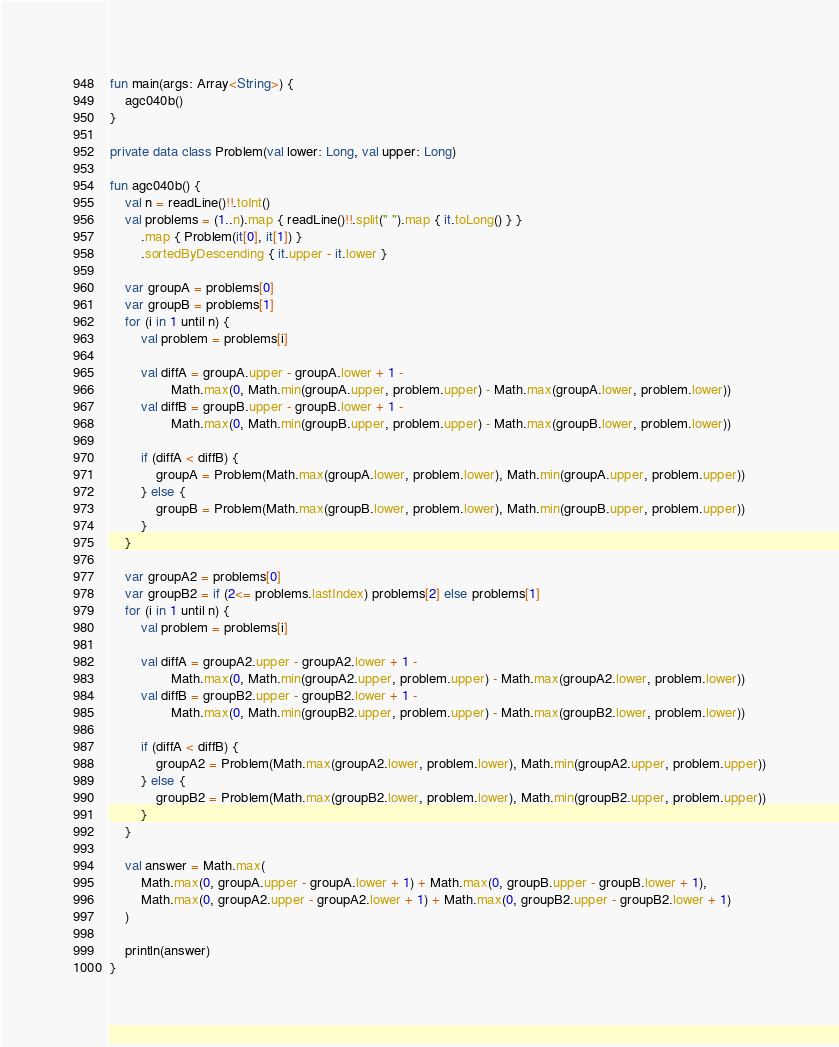<code> <loc_0><loc_0><loc_500><loc_500><_Kotlin_>fun main(args: Array<String>) {
    agc040b()
}

private data class Problem(val lower: Long, val upper: Long)

fun agc040b() {
    val n = readLine()!!.toInt()
    val problems = (1..n).map { readLine()!!.split(" ").map { it.toLong() } }
        .map { Problem(it[0], it[1]) }
        .sortedByDescending { it.upper - it.lower }

    var groupA = problems[0]
    var groupB = problems[1]
    for (i in 1 until n) {
        val problem = problems[i]

        val diffA = groupA.upper - groupA.lower + 1 -
                Math.max(0, Math.min(groupA.upper, problem.upper) - Math.max(groupA.lower, problem.lower))
        val diffB = groupB.upper - groupB.lower + 1 -
                Math.max(0, Math.min(groupB.upper, problem.upper) - Math.max(groupB.lower, problem.lower))

        if (diffA < diffB) {
            groupA = Problem(Math.max(groupA.lower, problem.lower), Math.min(groupA.upper, problem.upper))
        } else {
            groupB = Problem(Math.max(groupB.lower, problem.lower), Math.min(groupB.upper, problem.upper))
        }
    }

    var groupA2 = problems[0]
    var groupB2 = if (2<= problems.lastIndex) problems[2] else problems[1]
    for (i in 1 until n) {
        val problem = problems[i]

        val diffA = groupA2.upper - groupA2.lower + 1 -
                Math.max(0, Math.min(groupA2.upper, problem.upper) - Math.max(groupA2.lower, problem.lower))
        val diffB = groupB2.upper - groupB2.lower + 1 -
                Math.max(0, Math.min(groupB2.upper, problem.upper) - Math.max(groupB2.lower, problem.lower))

        if (diffA < diffB) {
            groupA2 = Problem(Math.max(groupA2.lower, problem.lower), Math.min(groupA2.upper, problem.upper))
        } else {
            groupB2 = Problem(Math.max(groupB2.lower, problem.lower), Math.min(groupB2.upper, problem.upper))
        }
    }

    val answer = Math.max(
        Math.max(0, groupA.upper - groupA.lower + 1) + Math.max(0, groupB.upper - groupB.lower + 1),
        Math.max(0, groupA2.upper - groupA2.lower + 1) + Math.max(0, groupB2.upper - groupB2.lower + 1)
    )

    println(answer)
}
</code> 